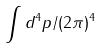<formula> <loc_0><loc_0><loc_500><loc_500>\int d ^ { 4 } p / ( 2 \pi ) ^ { 4 }</formula> 